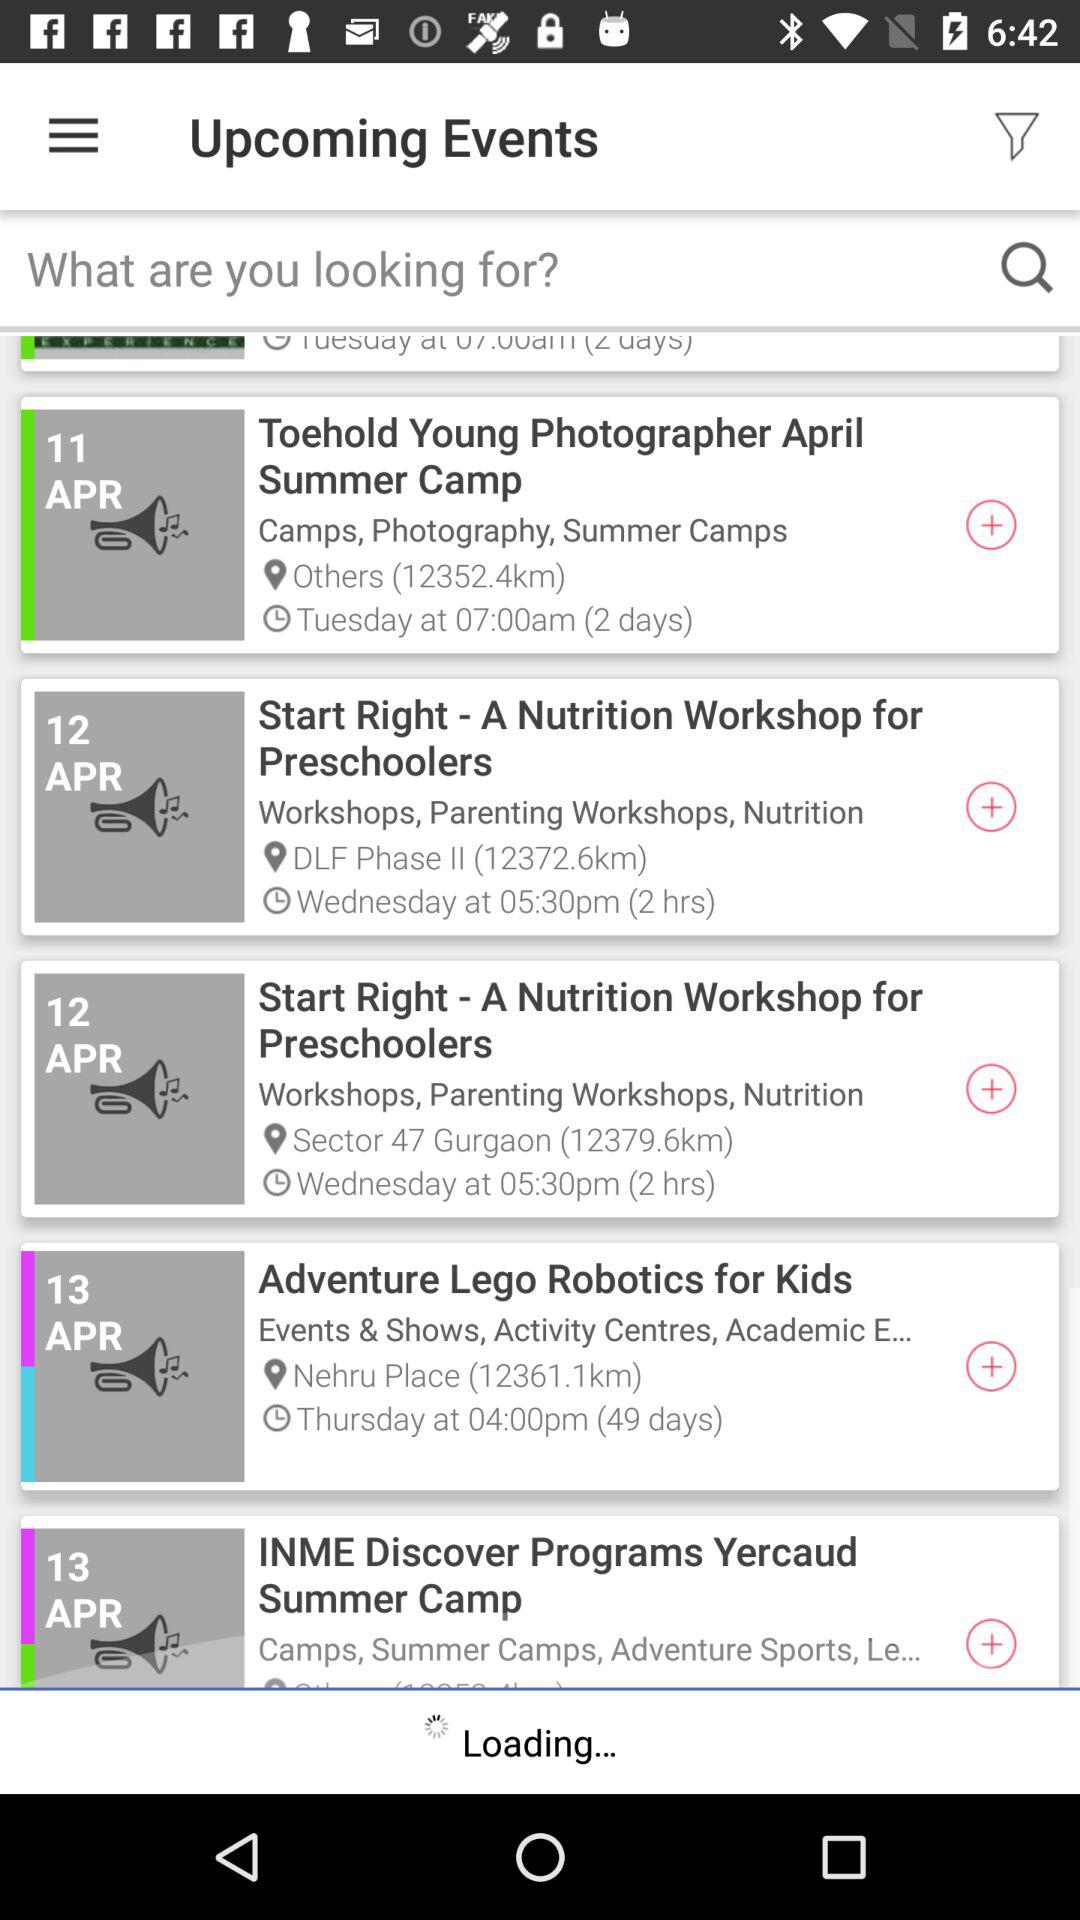What is the location of "Adventure Lego Robotics for Kids"? The location is Nehru Place. 